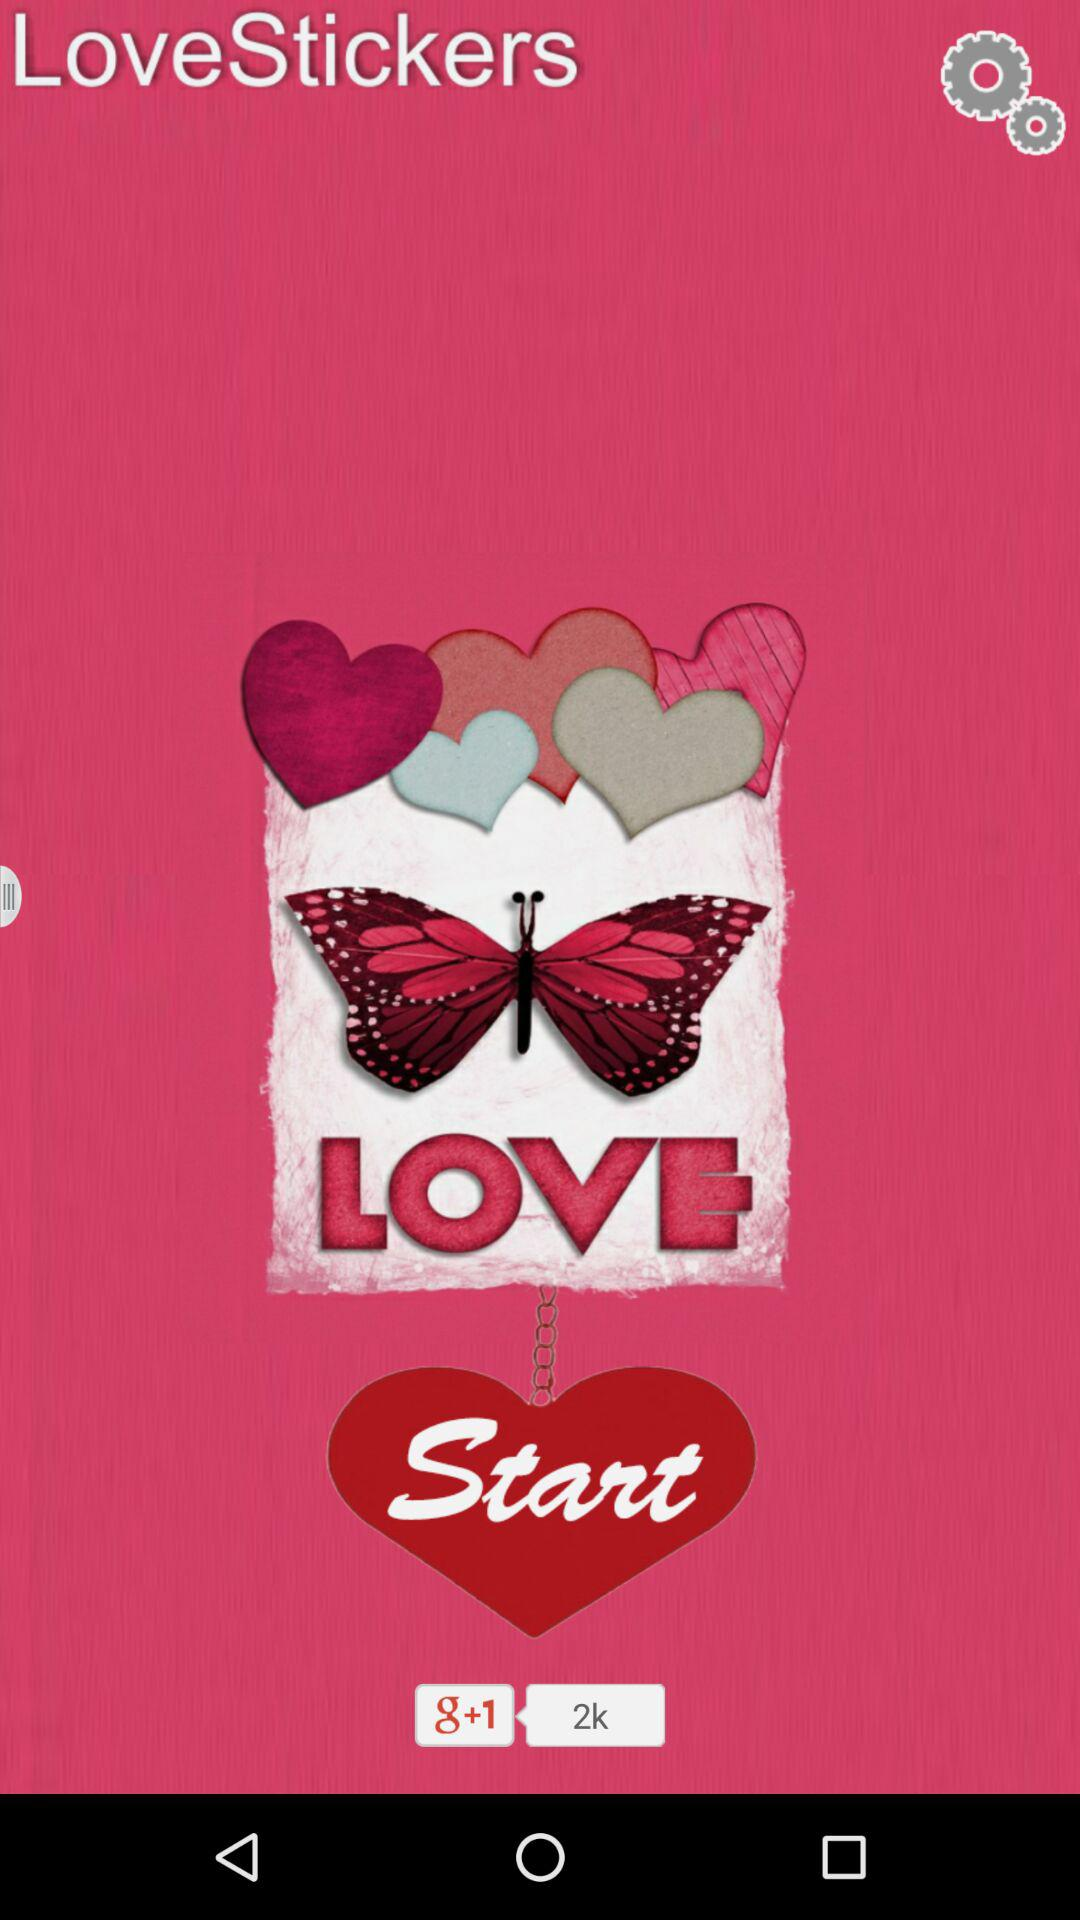What is the application name? The application name is "LoveStickers". 